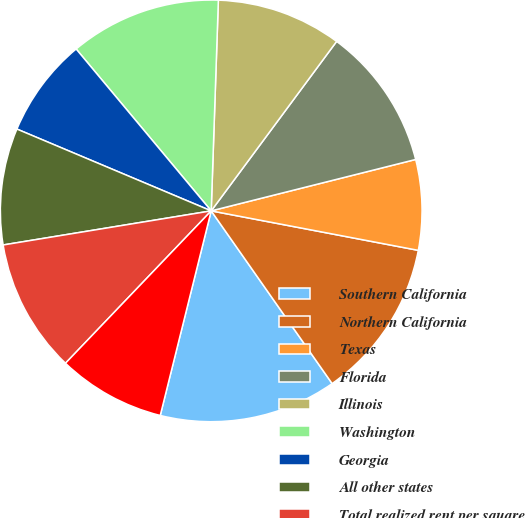Convert chart to OTSL. <chart><loc_0><loc_0><loc_500><loc_500><pie_chart><fcel>Southern California<fcel>Northern California<fcel>Texas<fcel>Florida<fcel>Illinois<fcel>Washington<fcel>Georgia<fcel>All other states<fcel>Total realized rent per square<fcel>Total REVPAF<nl><fcel>13.61%<fcel>12.28%<fcel>6.92%<fcel>10.94%<fcel>9.6%<fcel>11.61%<fcel>7.59%<fcel>8.93%<fcel>10.27%<fcel>8.26%<nl></chart> 